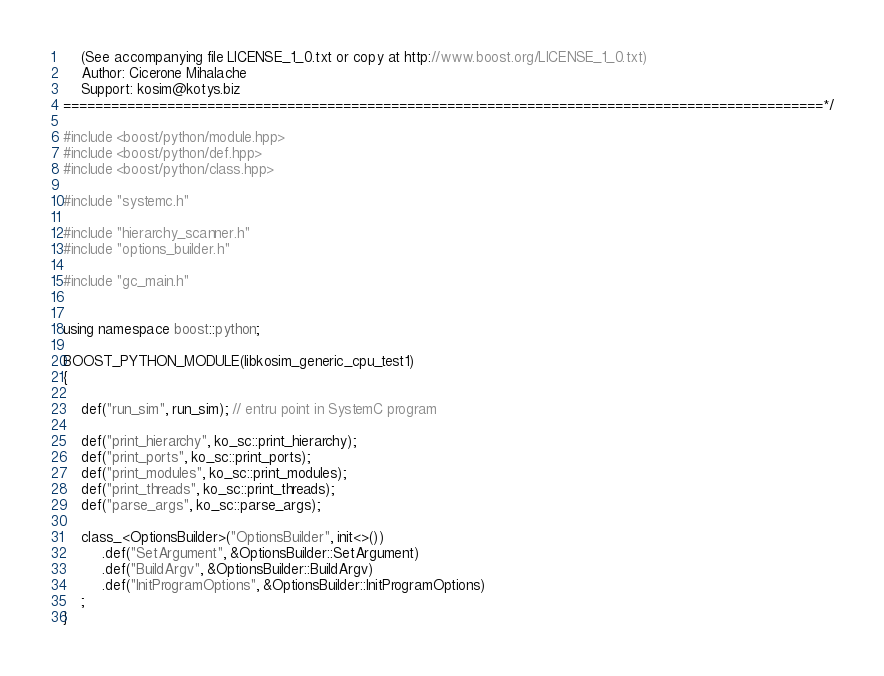<code> <loc_0><loc_0><loc_500><loc_500><_C++_>    (See accompanying file LICENSE_1_0.txt or copy at http://www.boost.org/LICENSE_1_0.txt)
    Author: Cicerone Mihalache                                     
    Support: kosim@kotys.biz 
===============================================================================================*/

#include <boost/python/module.hpp>
#include <boost/python/def.hpp>
#include <boost/python/class.hpp> 

#include "systemc.h"
 
#include "hierarchy_scanner.h"
#include "options_builder.h"

#include "gc_main.h"


using namespace boost::python;

BOOST_PYTHON_MODULE(libkosim_generic_cpu_test1)
{

    def("run_sim", run_sim); // entru point in SystemC program                           

    def("print_hierarchy", ko_sc::print_hierarchy);
    def("print_ports", ko_sc::print_ports);
    def("print_modules", ko_sc::print_modules);
    def("print_threads", ko_sc::print_threads);
    def("parse_args", ko_sc::parse_args);

    class_<OptionsBuilder>("OptionsBuilder", init<>())
         .def("SetArgument", &OptionsBuilder::SetArgument) 
         .def("BuildArgv", &OptionsBuilder::BuildArgv) 
         .def("InitProgramOptions", &OptionsBuilder::InitProgramOptions) 
    ;
}


</code> 